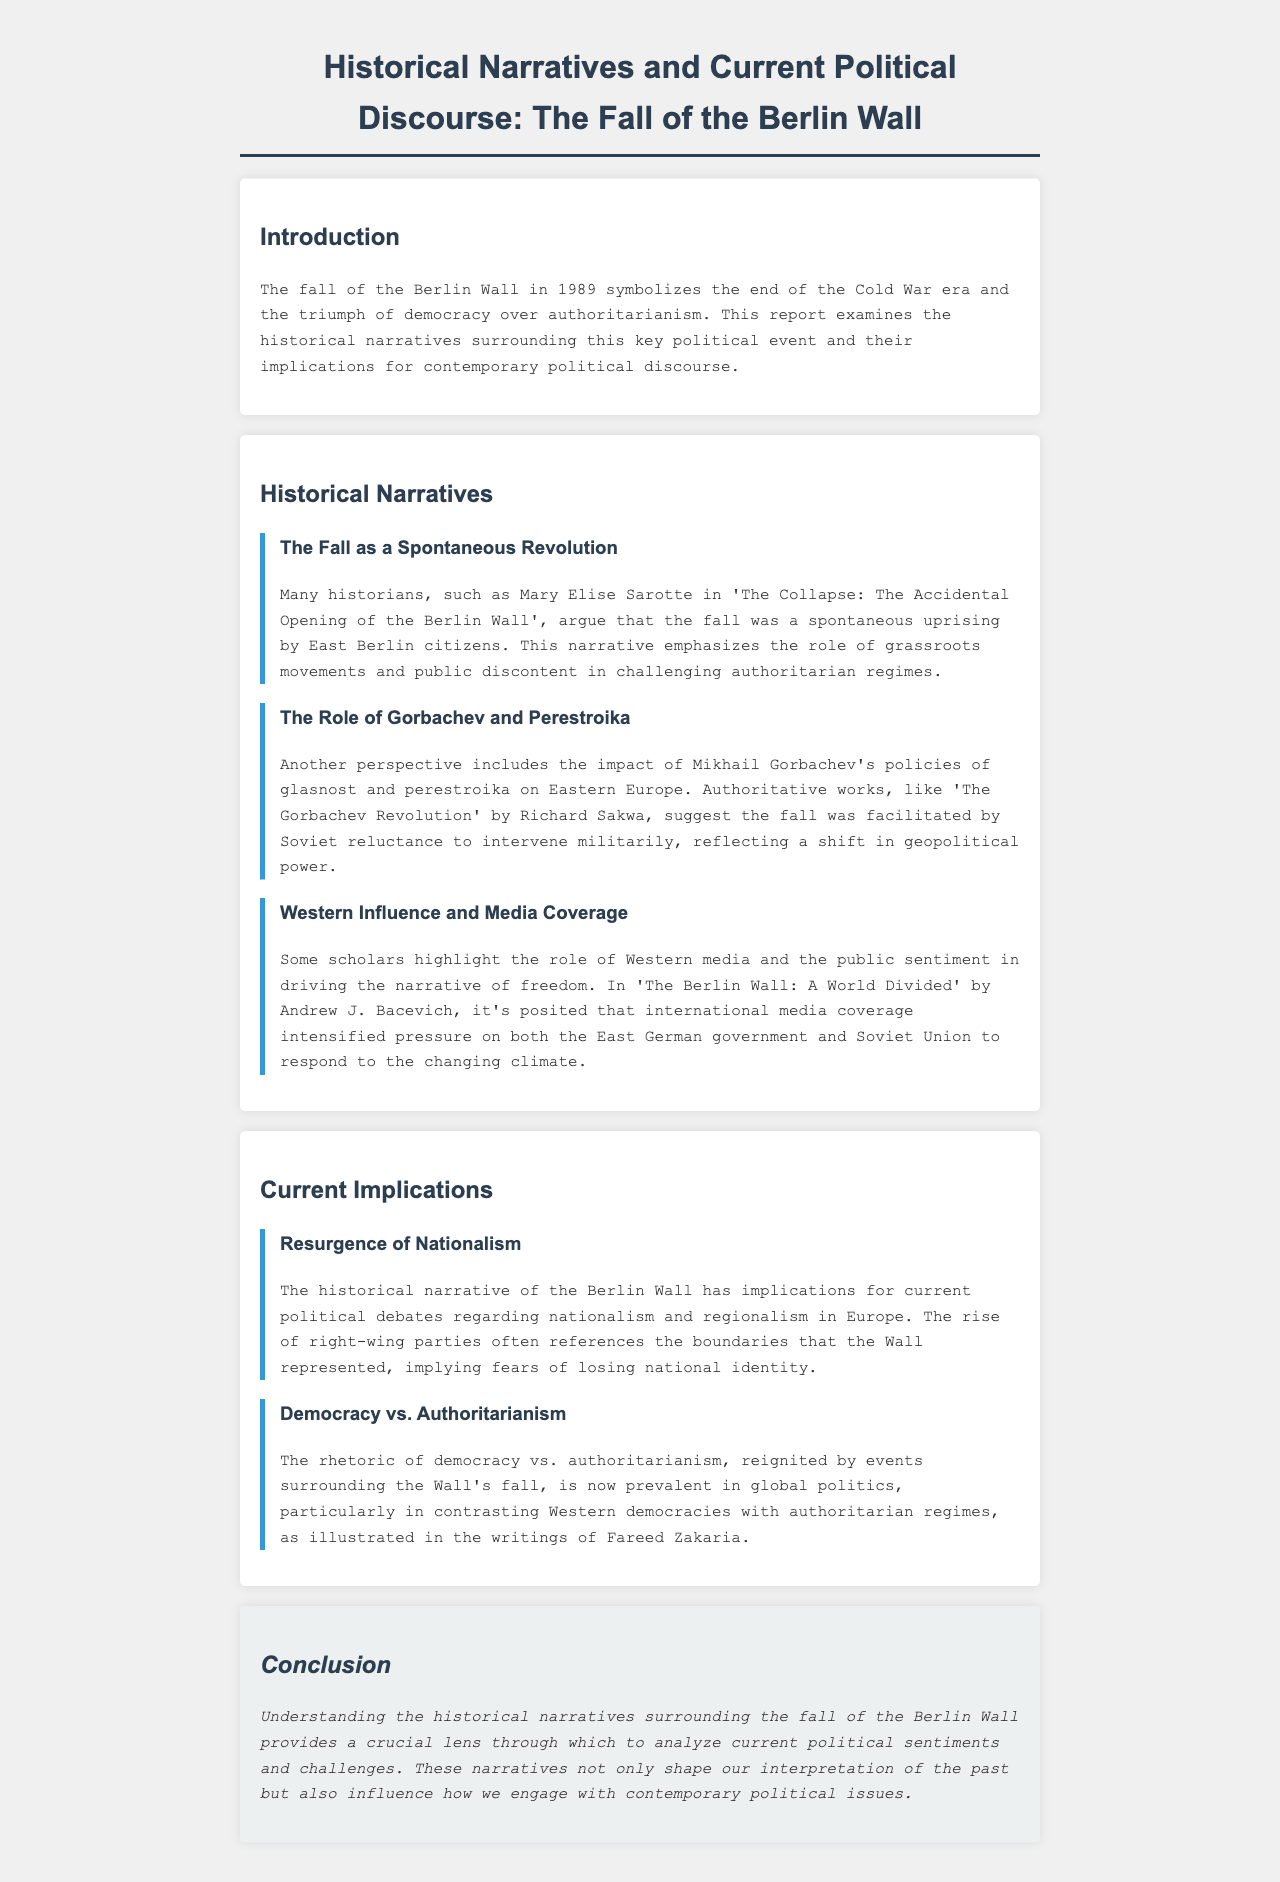What year did the Berlin Wall fall? The document mentions that the fall of the Berlin Wall occurred in 1989.
Answer: 1989 Who wrote "The Collapse: The Accidental Opening of the Berlin Wall"? The historian referenced for this narrative is Mary Elise Sarotte.
Answer: Mary Elise Sarotte What term describes Gorbachev's policies that impacted Eastern Europe? The document refers to Gorbachev's policies as glasnost and perestroika.
Answer: glasnost and perestroika What is a key implication of the historical narrative discussed? The document states that the resurgence of nationalism is a key current implication.
Answer: resurgence of nationalism Which historian suggested the fall was facilitated by Soviet reluctance? Richard Sakwa is mentioned as the author of "The Gorbachev Revolution," which supports this view.
Answer: Richard Sakwa What major political dichotomy is reignited by the fall of the Berlin Wall? The document discusses the rhetoric of democracy vs. authoritarianism as a major political dichotomy.
Answer: democracy vs. authoritarianism What role did Western media play according to the document? It is posited that Western media intensified pressure on the East German government and Soviet Union.
Answer: intensified pressure Who authored "The Berlin Wall: A World Divided"? Andrew J. Bacevich wrote "The Berlin Wall: A World Divided."
Answer: Andrew J. Bacevich 